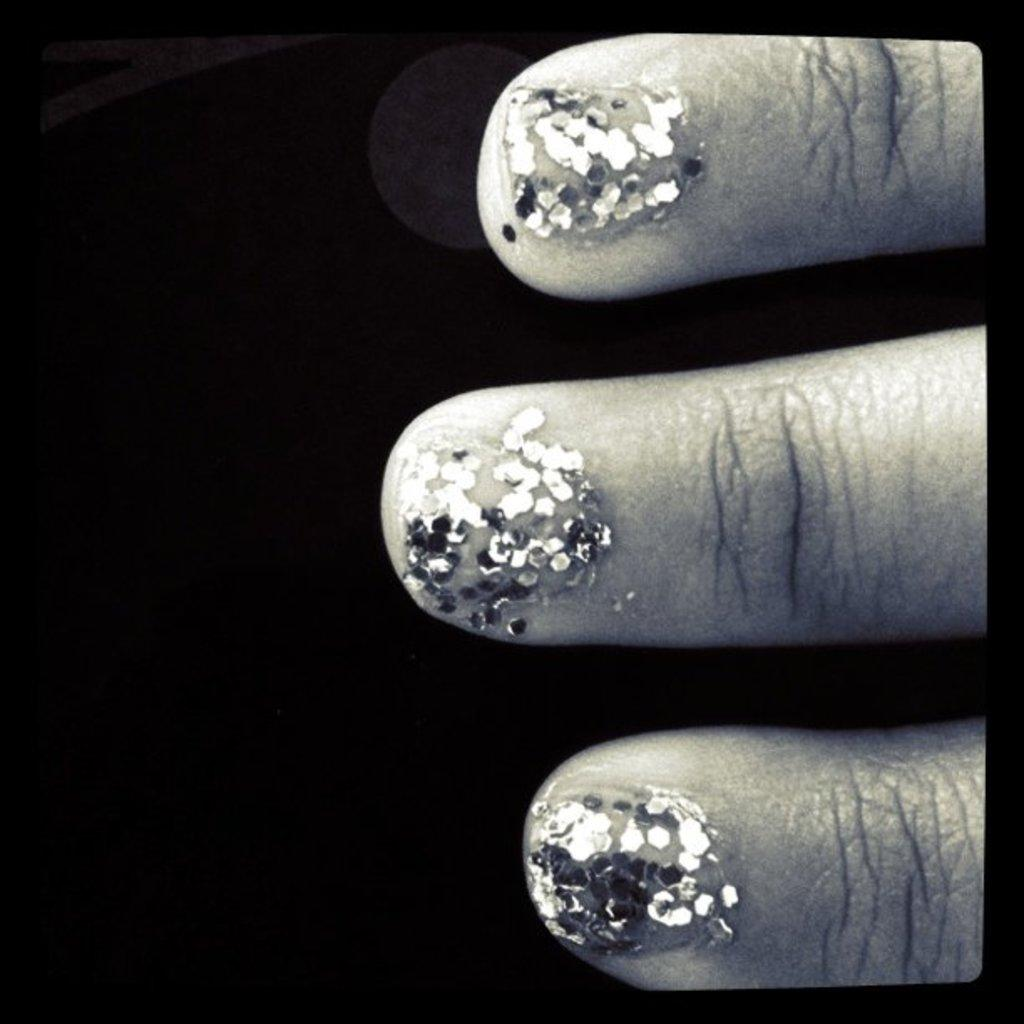What is the main subject of the image? The main subject of the image is three fingers. What can be observed on the nails of the fingers? There is glitter nail paint on the nails. What type of flag is waving in the background of the image? There is no flag present in the image; it only features three fingers with glitter nail paint. 